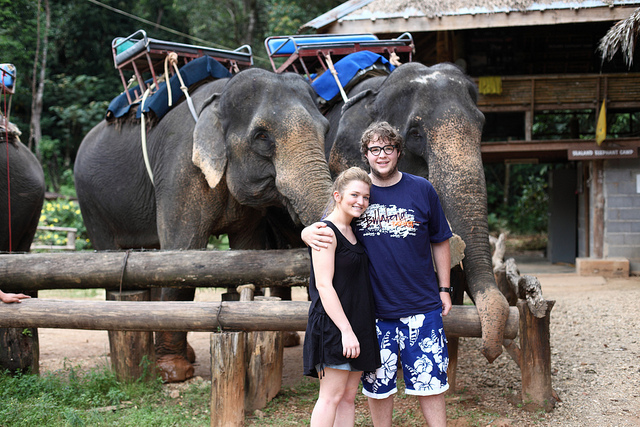What is the setting of this image? The photo seems to have been taken in a location that offers elephant riding experiences, possibly a sanctuary or tourist attraction in a region where these animals are native. Do the elephants seem well cared for in this environment? While the elephants appear to be calm, evaluating their well-being requires more information on their physical health, the care they receive, and the conditions they live in. Ethical practices vary greatly between such establishments. 